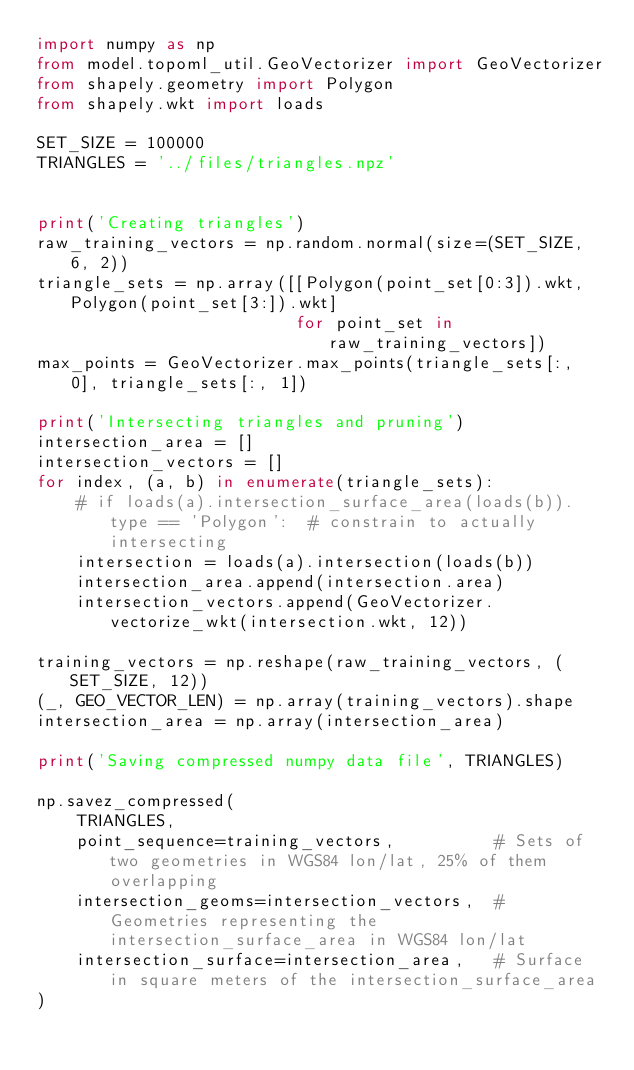Convert code to text. <code><loc_0><loc_0><loc_500><loc_500><_Python_>import numpy as np
from model.topoml_util.GeoVectorizer import GeoVectorizer
from shapely.geometry import Polygon
from shapely.wkt import loads

SET_SIZE = 100000
TRIANGLES = '../files/triangles.npz'


print('Creating triangles')
raw_training_vectors = np.random.normal(size=(SET_SIZE, 6, 2))
triangle_sets = np.array([[Polygon(point_set[0:3]).wkt, Polygon(point_set[3:]).wkt]
                          for point_set in raw_training_vectors])
max_points = GeoVectorizer.max_points(triangle_sets[:, 0], triangle_sets[:, 1])

print('Intersecting triangles and pruning')
intersection_area = []
intersection_vectors = []
for index, (a, b) in enumerate(triangle_sets):
    # if loads(a).intersection_surface_area(loads(b)).type == 'Polygon':  # constrain to actually intersecting
    intersection = loads(a).intersection(loads(b))
    intersection_area.append(intersection.area)
    intersection_vectors.append(GeoVectorizer.vectorize_wkt(intersection.wkt, 12))

training_vectors = np.reshape(raw_training_vectors, (SET_SIZE, 12))
(_, GEO_VECTOR_LEN) = np.array(training_vectors).shape
intersection_area = np.array(intersection_area)

print('Saving compressed numpy data file', TRIANGLES)

np.savez_compressed(
    TRIANGLES,
    point_sequence=training_vectors,          # Sets of two geometries in WGS84 lon/lat, 25% of them overlapping
    intersection_geoms=intersection_vectors,  # Geometries representing the intersection_surface_area in WGS84 lon/lat
    intersection_surface=intersection_area,   # Surface in square meters of the intersection_surface_area
)</code> 